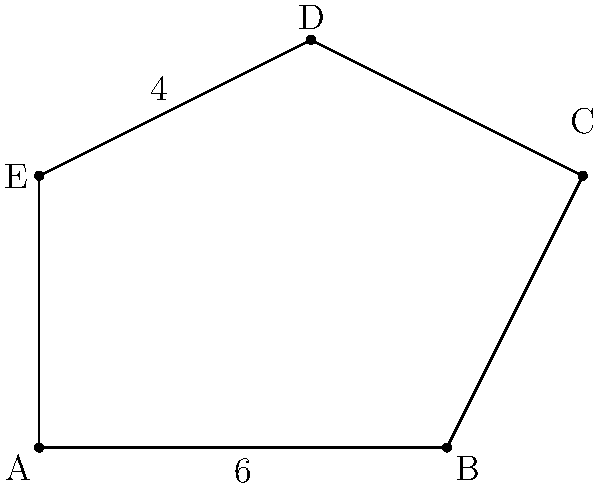At a music festival, you're tasked with calculating the length of LED strips needed to outline an irregularly shaped stage platform. The platform's shape is represented by the coordinates of its vertices: A(0,0), B(6,0), C(8,4), D(4,6), and E(0,4). What is the perimeter of the stage platform? To find the perimeter, we need to calculate the distance between each consecutive pair of vertices and sum them up. We'll use the distance formula: $d = \sqrt{(x_2-x_1)^2 + (y_2-y_1)^2}$

1. Distance AB: $\sqrt{(6-0)^2 + (0-0)^2} = 6$

2. Distance BC: $\sqrt{(8-6)^2 + (4-0)^2} = \sqrt{4 + 16} = \sqrt{20} = 2\sqrt{5}$

3. Distance CD: $\sqrt{(4-8)^2 + (6-4)^2} = \sqrt{16 + 4} = \sqrt{20} = 2\sqrt{5}$

4. Distance DE: $\sqrt{(0-4)^2 + (4-6)^2} = \sqrt{16 + 4} = \sqrt{20} = 2\sqrt{5}$

5. Distance EA: $\sqrt{(0-0)^2 + (0-4)^2} = 4$

Sum of all distances:
$$ 6 + 2\sqrt{5} + 2\sqrt{5} + 2\sqrt{5} + 4 = 10 + 6\sqrt{5} $$

Therefore, the perimeter of the stage platform is $10 + 6\sqrt{5}$ units.
Answer: $10 + 6\sqrt{5}$ units 